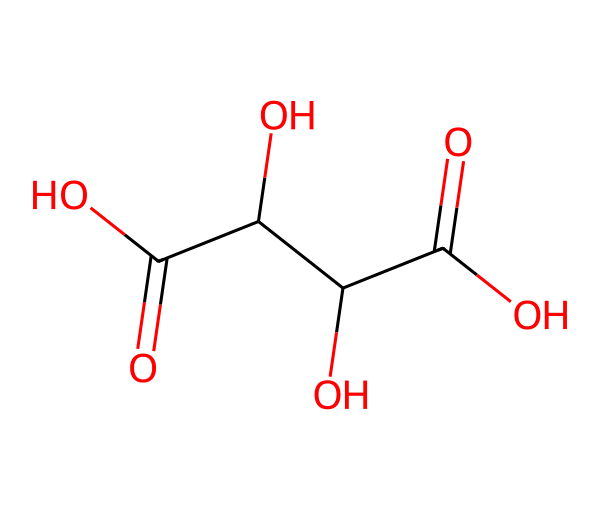What is the name of this acid? The chemical structure corresponds to tartaric acid, which is recognizable by its specific arrangement of carboxylic acid groups (-COOH) and hydroxyl groups (-OH) in the molecule.
Answer: tartaric acid How many carboxylic acid groups are present? By examining the structure, there are two carboxylic acid functional groups (-COOH) that indicate the presence of two acidic protons.
Answer: two What is the total number of hydroxyl groups in the molecule? The structure reveals that there are two hydroxyl groups (-OH) attached to the carbon backbone, contributing to its acidic properties.
Answer: two Why is tartaric acid significant in kosher wine production? Tartaric acid helps in stabilizing the wine's taste and quality; it acts as a natural acidulant and is essential for achieving the desired acidity level, which is important for kosher wine standards.
Answer: stabilizing wine What type of acid is tartaric acid classified as? Tartaric acid is classified primarily as a dicarboxylic acid because it contains two -COOH groups. This classification helps to understand its reactivity and behavior in chemical processes.
Answer: dicarboxylic acid Does tartaric acid form any salts? Yes, tartaric acid can form salts called tartrates, which are important in various applications including wine stabilization and can contribute to the characteristic taste of wines.
Answer: yes 